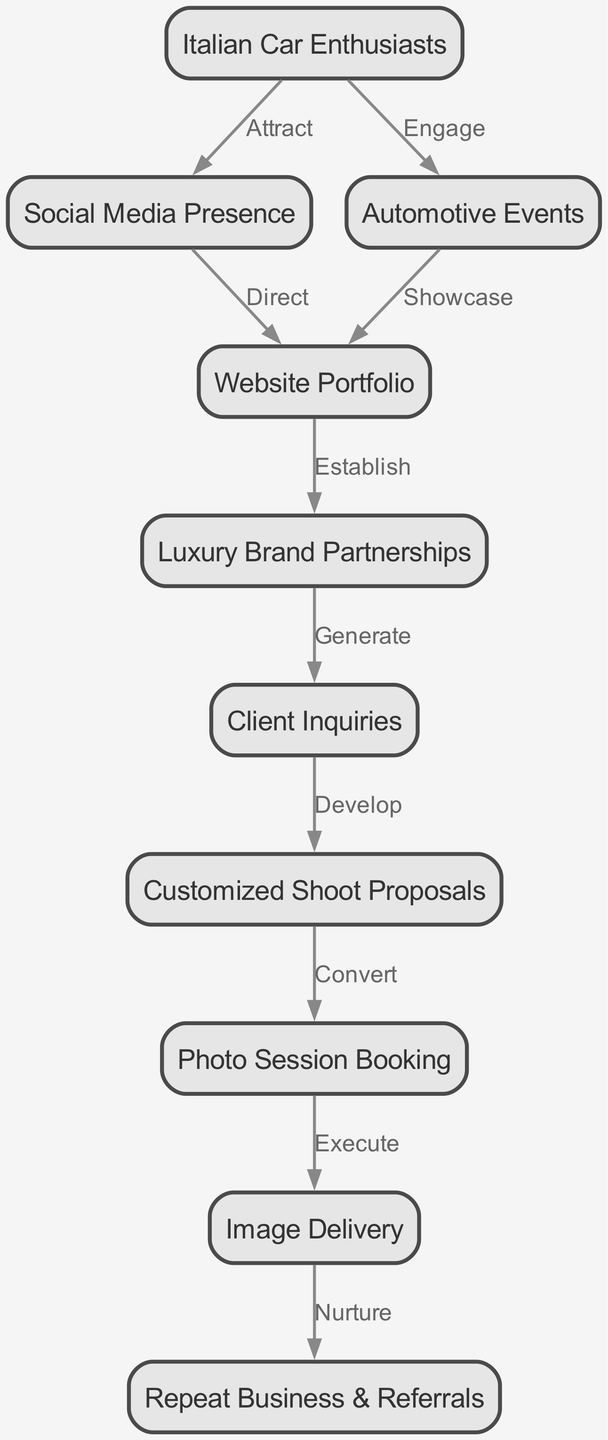What is the starting node in the marketing funnel? The starting node is "Italian Car Enthusiasts," which indicates the target audience for the photography business. The diagram clearly leads from this node to others, signifying the beginning of the funnel.
Answer: Italian Car Enthusiasts How many nodes are present in the diagram? To find the total number of nodes, we can count each unique item within the "nodes" section of the data provided. There are ten distinct entries listed.
Answer: Ten What label connects "Social Media Presence" and "Website Portfolio"? The edge between "Social Media Presence" and "Website Portfolio" is labeled "Direct," which indicates the way social media effectively guides potential clients to the portfolio.
Answer: Direct What is the final result of the marketing funnel? The final outcome of the funnel as depicted is "Repeat Business & Referrals," which represents the ultimate goal of client satisfaction leading to further engagements.
Answer: Repeat Business & Referrals Which node is directly connected to "Client Inquiries"? The node directly connected to "Client Inquiries" is "Customized Shoot Proposals." This indicates the step following an inquiry, showcasing how the workflow progresses.
Answer: Customized Shoot Proposals How does "Luxury Brand Partnerships" influence the funnel? "Luxury Brand Partnerships" generates "Client Inquiries," illustrating a direct effect where partnerships with brands lead to increased inquiries from potential clients.
Answer: Generate What pathway does a client take from "Photo Session Booking" to the final node? Following the path from "Photo Session Booking," a client moves to "Image Delivery," and subsequently, this leads to the final outcome, "Repeat Business & Referrals." This highlights the importance of timely image delivery in customer retention.
Answer: Image Delivery to Repeat Business & Referrals What is the label on the edge connecting "Website Portfolio" and "Luxury Brand Partnerships"? The edge connecting these nodes is labeled "Establish," indicating the role of a strong portfolio in fostering partnerships with luxury brands.
Answer: Establish 